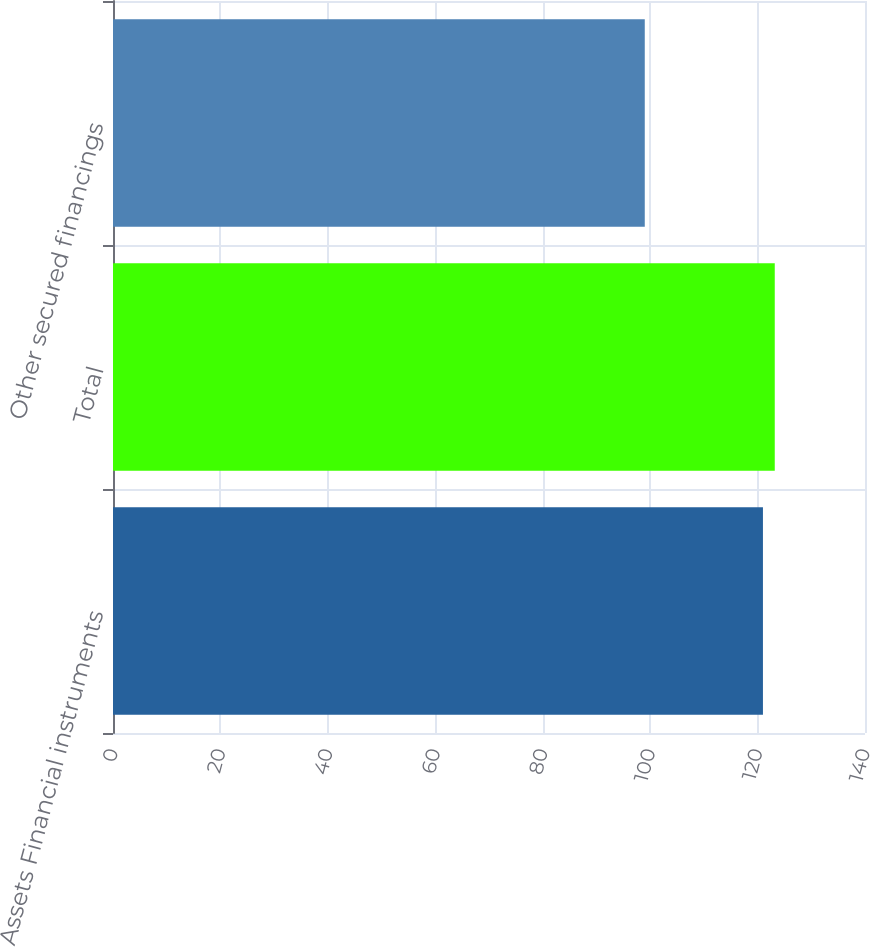<chart> <loc_0><loc_0><loc_500><loc_500><bar_chart><fcel>Assets Financial instruments<fcel>Total<fcel>Other secured financings<nl><fcel>121<fcel>123.2<fcel>99<nl></chart> 